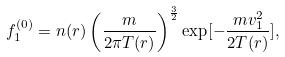Convert formula to latex. <formula><loc_0><loc_0><loc_500><loc_500>f ^ { ( 0 ) } _ { 1 } = n ( { r } ) \left ( \frac { m } { 2 \pi T ( { r } ) } \right ) ^ { \frac { 3 } { 2 } } \exp [ - \frac { m { v } _ { 1 } ^ { 2 } } { 2 T ( { r } ) } ] ,</formula> 